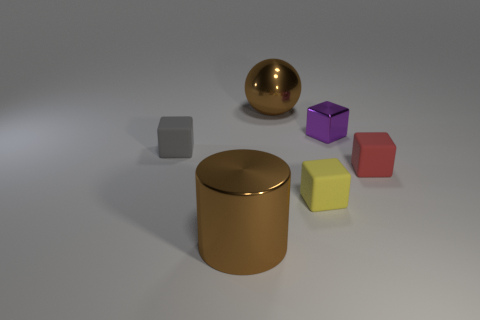Add 2 big green metal things. How many objects exist? 8 Subtract all small yellow cubes. How many cubes are left? 3 Subtract all balls. How many objects are left? 5 Add 5 small metal spheres. How many small metal spheres exist? 5 Subtract all yellow blocks. How many blocks are left? 3 Subtract 0 cyan cylinders. How many objects are left? 6 Subtract 1 balls. How many balls are left? 0 Subtract all gray cylinders. Subtract all gray spheres. How many cylinders are left? 1 Subtract all red cubes. Subtract all brown things. How many objects are left? 3 Add 6 small rubber things. How many small rubber things are left? 9 